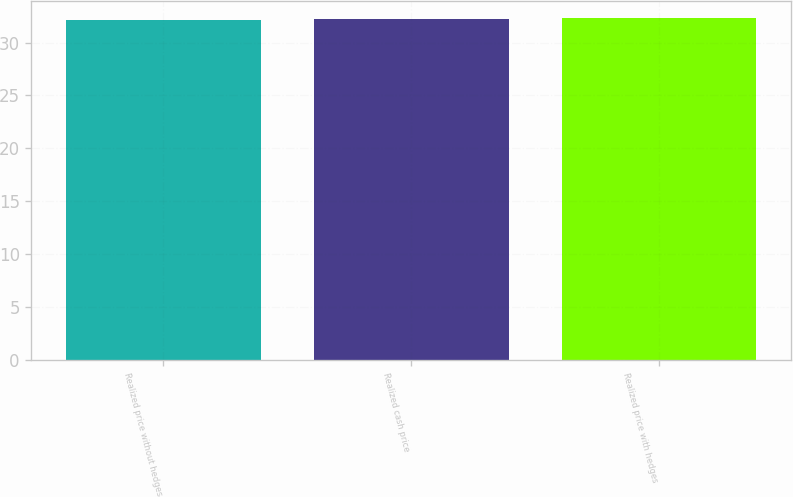<chart> <loc_0><loc_0><loc_500><loc_500><bar_chart><fcel>Realized price without hedges<fcel>Realized cash price<fcel>Realized price with hedges<nl><fcel>32.1<fcel>32.2<fcel>32.3<nl></chart> 